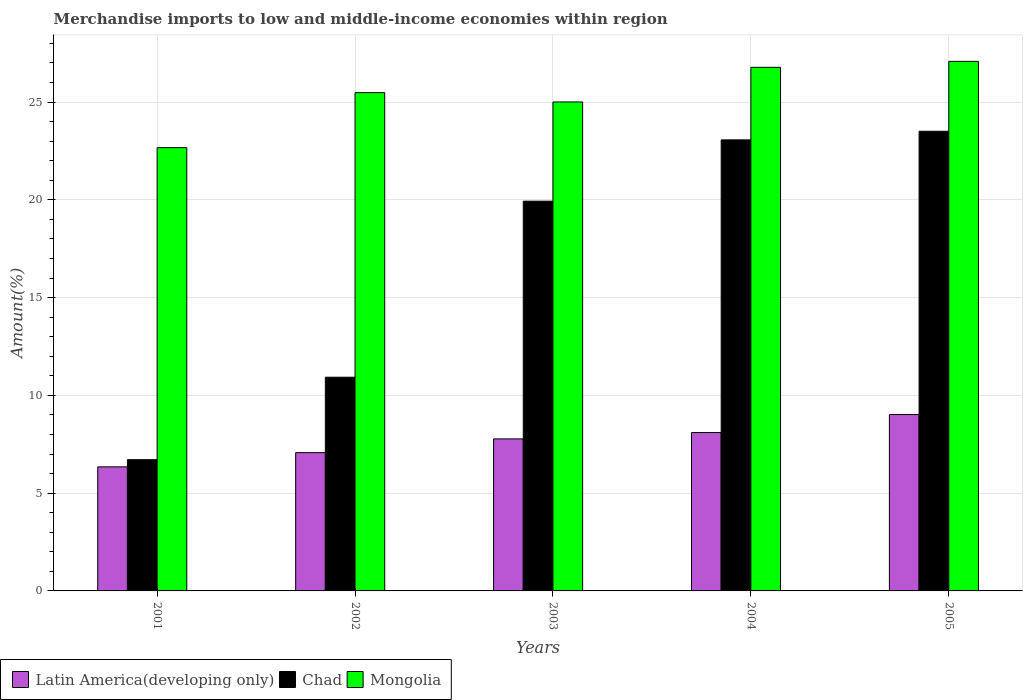Are the number of bars per tick equal to the number of legend labels?
Your response must be concise. Yes. Are the number of bars on each tick of the X-axis equal?
Offer a terse response. Yes. How many bars are there on the 4th tick from the right?
Your answer should be compact. 3. What is the label of the 1st group of bars from the left?
Your answer should be very brief. 2001. What is the percentage of amount earned from merchandise imports in Chad in 2005?
Offer a very short reply. 23.51. Across all years, what is the maximum percentage of amount earned from merchandise imports in Chad?
Offer a terse response. 23.51. Across all years, what is the minimum percentage of amount earned from merchandise imports in Mongolia?
Your answer should be compact. 22.67. In which year was the percentage of amount earned from merchandise imports in Chad maximum?
Your answer should be compact. 2005. What is the total percentage of amount earned from merchandise imports in Mongolia in the graph?
Offer a terse response. 127.01. What is the difference between the percentage of amount earned from merchandise imports in Chad in 2001 and that in 2003?
Provide a succinct answer. -13.22. What is the difference between the percentage of amount earned from merchandise imports in Mongolia in 2005 and the percentage of amount earned from merchandise imports in Latin America(developing only) in 2003?
Make the answer very short. 19.31. What is the average percentage of amount earned from merchandise imports in Chad per year?
Make the answer very short. 16.83. In the year 2003, what is the difference between the percentage of amount earned from merchandise imports in Chad and percentage of amount earned from merchandise imports in Mongolia?
Your response must be concise. -5.07. In how many years, is the percentage of amount earned from merchandise imports in Latin America(developing only) greater than 14 %?
Your answer should be very brief. 0. What is the ratio of the percentage of amount earned from merchandise imports in Latin America(developing only) in 2001 to that in 2004?
Ensure brevity in your answer.  0.78. What is the difference between the highest and the second highest percentage of amount earned from merchandise imports in Mongolia?
Keep it short and to the point. 0.3. What is the difference between the highest and the lowest percentage of amount earned from merchandise imports in Latin America(developing only)?
Keep it short and to the point. 2.68. What does the 3rd bar from the left in 2003 represents?
Provide a short and direct response. Mongolia. What does the 3rd bar from the right in 2002 represents?
Your answer should be very brief. Latin America(developing only). Are all the bars in the graph horizontal?
Offer a very short reply. No. How many years are there in the graph?
Your answer should be compact. 5. Does the graph contain any zero values?
Keep it short and to the point. No. Where does the legend appear in the graph?
Provide a succinct answer. Bottom left. How many legend labels are there?
Offer a terse response. 3. How are the legend labels stacked?
Provide a short and direct response. Horizontal. What is the title of the graph?
Make the answer very short. Merchandise imports to low and middle-income economies within region. Does "Sao Tome and Principe" appear as one of the legend labels in the graph?
Ensure brevity in your answer.  No. What is the label or title of the X-axis?
Provide a succinct answer. Years. What is the label or title of the Y-axis?
Keep it short and to the point. Amount(%). What is the Amount(%) in Latin America(developing only) in 2001?
Provide a short and direct response. 6.34. What is the Amount(%) in Chad in 2001?
Keep it short and to the point. 6.71. What is the Amount(%) in Mongolia in 2001?
Your answer should be compact. 22.67. What is the Amount(%) of Latin America(developing only) in 2002?
Keep it short and to the point. 7.07. What is the Amount(%) in Chad in 2002?
Ensure brevity in your answer.  10.93. What is the Amount(%) in Mongolia in 2002?
Ensure brevity in your answer.  25.48. What is the Amount(%) of Latin America(developing only) in 2003?
Offer a very short reply. 7.77. What is the Amount(%) in Chad in 2003?
Make the answer very short. 19.93. What is the Amount(%) of Mongolia in 2003?
Ensure brevity in your answer.  25. What is the Amount(%) of Latin America(developing only) in 2004?
Offer a terse response. 8.1. What is the Amount(%) of Chad in 2004?
Keep it short and to the point. 23.06. What is the Amount(%) in Mongolia in 2004?
Your response must be concise. 26.78. What is the Amount(%) in Latin America(developing only) in 2005?
Offer a terse response. 9.02. What is the Amount(%) of Chad in 2005?
Your answer should be very brief. 23.51. What is the Amount(%) in Mongolia in 2005?
Offer a terse response. 27.08. Across all years, what is the maximum Amount(%) of Latin America(developing only)?
Your response must be concise. 9.02. Across all years, what is the maximum Amount(%) of Chad?
Provide a succinct answer. 23.51. Across all years, what is the maximum Amount(%) in Mongolia?
Your response must be concise. 27.08. Across all years, what is the minimum Amount(%) in Latin America(developing only)?
Your answer should be very brief. 6.34. Across all years, what is the minimum Amount(%) of Chad?
Your answer should be very brief. 6.71. Across all years, what is the minimum Amount(%) of Mongolia?
Ensure brevity in your answer.  22.67. What is the total Amount(%) of Latin America(developing only) in the graph?
Offer a very short reply. 38.31. What is the total Amount(%) in Chad in the graph?
Give a very brief answer. 84.14. What is the total Amount(%) in Mongolia in the graph?
Keep it short and to the point. 127.01. What is the difference between the Amount(%) of Latin America(developing only) in 2001 and that in 2002?
Your response must be concise. -0.73. What is the difference between the Amount(%) in Chad in 2001 and that in 2002?
Ensure brevity in your answer.  -4.22. What is the difference between the Amount(%) of Mongolia in 2001 and that in 2002?
Keep it short and to the point. -2.81. What is the difference between the Amount(%) of Latin America(developing only) in 2001 and that in 2003?
Give a very brief answer. -1.43. What is the difference between the Amount(%) in Chad in 2001 and that in 2003?
Provide a succinct answer. -13.22. What is the difference between the Amount(%) in Mongolia in 2001 and that in 2003?
Give a very brief answer. -2.34. What is the difference between the Amount(%) in Latin America(developing only) in 2001 and that in 2004?
Ensure brevity in your answer.  -1.75. What is the difference between the Amount(%) of Chad in 2001 and that in 2004?
Make the answer very short. -16.35. What is the difference between the Amount(%) of Mongolia in 2001 and that in 2004?
Offer a very short reply. -4.11. What is the difference between the Amount(%) of Latin America(developing only) in 2001 and that in 2005?
Your answer should be very brief. -2.68. What is the difference between the Amount(%) in Chad in 2001 and that in 2005?
Your answer should be compact. -16.8. What is the difference between the Amount(%) in Mongolia in 2001 and that in 2005?
Ensure brevity in your answer.  -4.41. What is the difference between the Amount(%) in Latin America(developing only) in 2002 and that in 2003?
Provide a short and direct response. -0.7. What is the difference between the Amount(%) in Chad in 2002 and that in 2003?
Provide a succinct answer. -9. What is the difference between the Amount(%) in Mongolia in 2002 and that in 2003?
Offer a terse response. 0.48. What is the difference between the Amount(%) of Latin America(developing only) in 2002 and that in 2004?
Your answer should be very brief. -1.03. What is the difference between the Amount(%) in Chad in 2002 and that in 2004?
Your answer should be compact. -12.14. What is the difference between the Amount(%) in Mongolia in 2002 and that in 2004?
Your answer should be very brief. -1.29. What is the difference between the Amount(%) of Latin America(developing only) in 2002 and that in 2005?
Offer a terse response. -1.95. What is the difference between the Amount(%) of Chad in 2002 and that in 2005?
Ensure brevity in your answer.  -12.58. What is the difference between the Amount(%) in Mongolia in 2002 and that in 2005?
Give a very brief answer. -1.6. What is the difference between the Amount(%) in Latin America(developing only) in 2003 and that in 2004?
Make the answer very short. -0.33. What is the difference between the Amount(%) of Chad in 2003 and that in 2004?
Offer a very short reply. -3.13. What is the difference between the Amount(%) in Mongolia in 2003 and that in 2004?
Your response must be concise. -1.77. What is the difference between the Amount(%) of Latin America(developing only) in 2003 and that in 2005?
Your answer should be compact. -1.25. What is the difference between the Amount(%) in Chad in 2003 and that in 2005?
Your answer should be compact. -3.58. What is the difference between the Amount(%) of Mongolia in 2003 and that in 2005?
Keep it short and to the point. -2.08. What is the difference between the Amount(%) of Latin America(developing only) in 2004 and that in 2005?
Offer a terse response. -0.92. What is the difference between the Amount(%) in Chad in 2004 and that in 2005?
Keep it short and to the point. -0.44. What is the difference between the Amount(%) in Mongolia in 2004 and that in 2005?
Provide a succinct answer. -0.3. What is the difference between the Amount(%) in Latin America(developing only) in 2001 and the Amount(%) in Chad in 2002?
Provide a short and direct response. -4.58. What is the difference between the Amount(%) of Latin America(developing only) in 2001 and the Amount(%) of Mongolia in 2002?
Give a very brief answer. -19.14. What is the difference between the Amount(%) of Chad in 2001 and the Amount(%) of Mongolia in 2002?
Your answer should be very brief. -18.77. What is the difference between the Amount(%) of Latin America(developing only) in 2001 and the Amount(%) of Chad in 2003?
Offer a very short reply. -13.59. What is the difference between the Amount(%) of Latin America(developing only) in 2001 and the Amount(%) of Mongolia in 2003?
Make the answer very short. -18.66. What is the difference between the Amount(%) in Chad in 2001 and the Amount(%) in Mongolia in 2003?
Provide a short and direct response. -18.29. What is the difference between the Amount(%) in Latin America(developing only) in 2001 and the Amount(%) in Chad in 2004?
Your response must be concise. -16.72. What is the difference between the Amount(%) in Latin America(developing only) in 2001 and the Amount(%) in Mongolia in 2004?
Provide a short and direct response. -20.43. What is the difference between the Amount(%) of Chad in 2001 and the Amount(%) of Mongolia in 2004?
Offer a very short reply. -20.07. What is the difference between the Amount(%) in Latin America(developing only) in 2001 and the Amount(%) in Chad in 2005?
Your answer should be very brief. -17.16. What is the difference between the Amount(%) in Latin America(developing only) in 2001 and the Amount(%) in Mongolia in 2005?
Give a very brief answer. -20.74. What is the difference between the Amount(%) in Chad in 2001 and the Amount(%) in Mongolia in 2005?
Ensure brevity in your answer.  -20.37. What is the difference between the Amount(%) of Latin America(developing only) in 2002 and the Amount(%) of Chad in 2003?
Make the answer very short. -12.86. What is the difference between the Amount(%) of Latin America(developing only) in 2002 and the Amount(%) of Mongolia in 2003?
Offer a very short reply. -17.93. What is the difference between the Amount(%) of Chad in 2002 and the Amount(%) of Mongolia in 2003?
Give a very brief answer. -14.08. What is the difference between the Amount(%) in Latin America(developing only) in 2002 and the Amount(%) in Chad in 2004?
Make the answer very short. -15.99. What is the difference between the Amount(%) of Latin America(developing only) in 2002 and the Amount(%) of Mongolia in 2004?
Offer a terse response. -19.7. What is the difference between the Amount(%) of Chad in 2002 and the Amount(%) of Mongolia in 2004?
Make the answer very short. -15.85. What is the difference between the Amount(%) in Latin America(developing only) in 2002 and the Amount(%) in Chad in 2005?
Provide a short and direct response. -16.43. What is the difference between the Amount(%) of Latin America(developing only) in 2002 and the Amount(%) of Mongolia in 2005?
Offer a very short reply. -20.01. What is the difference between the Amount(%) of Chad in 2002 and the Amount(%) of Mongolia in 2005?
Keep it short and to the point. -16.15. What is the difference between the Amount(%) in Latin America(developing only) in 2003 and the Amount(%) in Chad in 2004?
Ensure brevity in your answer.  -15.29. What is the difference between the Amount(%) in Latin America(developing only) in 2003 and the Amount(%) in Mongolia in 2004?
Your answer should be very brief. -19. What is the difference between the Amount(%) of Chad in 2003 and the Amount(%) of Mongolia in 2004?
Your answer should be compact. -6.85. What is the difference between the Amount(%) of Latin America(developing only) in 2003 and the Amount(%) of Chad in 2005?
Give a very brief answer. -15.73. What is the difference between the Amount(%) of Latin America(developing only) in 2003 and the Amount(%) of Mongolia in 2005?
Give a very brief answer. -19.31. What is the difference between the Amount(%) in Chad in 2003 and the Amount(%) in Mongolia in 2005?
Make the answer very short. -7.15. What is the difference between the Amount(%) in Latin America(developing only) in 2004 and the Amount(%) in Chad in 2005?
Offer a very short reply. -15.41. What is the difference between the Amount(%) of Latin America(developing only) in 2004 and the Amount(%) of Mongolia in 2005?
Your answer should be very brief. -18.98. What is the difference between the Amount(%) in Chad in 2004 and the Amount(%) in Mongolia in 2005?
Give a very brief answer. -4.02. What is the average Amount(%) of Latin America(developing only) per year?
Provide a succinct answer. 7.66. What is the average Amount(%) in Chad per year?
Your answer should be compact. 16.83. What is the average Amount(%) in Mongolia per year?
Make the answer very short. 25.4. In the year 2001, what is the difference between the Amount(%) in Latin America(developing only) and Amount(%) in Chad?
Provide a succinct answer. -0.37. In the year 2001, what is the difference between the Amount(%) of Latin America(developing only) and Amount(%) of Mongolia?
Your answer should be compact. -16.32. In the year 2001, what is the difference between the Amount(%) in Chad and Amount(%) in Mongolia?
Offer a very short reply. -15.96. In the year 2002, what is the difference between the Amount(%) in Latin America(developing only) and Amount(%) in Chad?
Provide a short and direct response. -3.86. In the year 2002, what is the difference between the Amount(%) in Latin America(developing only) and Amount(%) in Mongolia?
Your answer should be very brief. -18.41. In the year 2002, what is the difference between the Amount(%) in Chad and Amount(%) in Mongolia?
Provide a short and direct response. -14.55. In the year 2003, what is the difference between the Amount(%) in Latin America(developing only) and Amount(%) in Chad?
Your answer should be very brief. -12.16. In the year 2003, what is the difference between the Amount(%) in Latin America(developing only) and Amount(%) in Mongolia?
Your answer should be compact. -17.23. In the year 2003, what is the difference between the Amount(%) in Chad and Amount(%) in Mongolia?
Provide a short and direct response. -5.07. In the year 2004, what is the difference between the Amount(%) of Latin America(developing only) and Amount(%) of Chad?
Give a very brief answer. -14.97. In the year 2004, what is the difference between the Amount(%) in Latin America(developing only) and Amount(%) in Mongolia?
Provide a short and direct response. -18.68. In the year 2004, what is the difference between the Amount(%) in Chad and Amount(%) in Mongolia?
Keep it short and to the point. -3.71. In the year 2005, what is the difference between the Amount(%) of Latin America(developing only) and Amount(%) of Chad?
Your answer should be compact. -14.49. In the year 2005, what is the difference between the Amount(%) of Latin America(developing only) and Amount(%) of Mongolia?
Provide a succinct answer. -18.06. In the year 2005, what is the difference between the Amount(%) of Chad and Amount(%) of Mongolia?
Offer a very short reply. -3.57. What is the ratio of the Amount(%) of Latin America(developing only) in 2001 to that in 2002?
Offer a terse response. 0.9. What is the ratio of the Amount(%) of Chad in 2001 to that in 2002?
Offer a very short reply. 0.61. What is the ratio of the Amount(%) in Mongolia in 2001 to that in 2002?
Offer a terse response. 0.89. What is the ratio of the Amount(%) of Latin America(developing only) in 2001 to that in 2003?
Provide a short and direct response. 0.82. What is the ratio of the Amount(%) of Chad in 2001 to that in 2003?
Your answer should be very brief. 0.34. What is the ratio of the Amount(%) in Mongolia in 2001 to that in 2003?
Make the answer very short. 0.91. What is the ratio of the Amount(%) of Latin America(developing only) in 2001 to that in 2004?
Offer a very short reply. 0.78. What is the ratio of the Amount(%) in Chad in 2001 to that in 2004?
Offer a very short reply. 0.29. What is the ratio of the Amount(%) of Mongolia in 2001 to that in 2004?
Ensure brevity in your answer.  0.85. What is the ratio of the Amount(%) in Latin America(developing only) in 2001 to that in 2005?
Give a very brief answer. 0.7. What is the ratio of the Amount(%) of Chad in 2001 to that in 2005?
Give a very brief answer. 0.29. What is the ratio of the Amount(%) of Mongolia in 2001 to that in 2005?
Your response must be concise. 0.84. What is the ratio of the Amount(%) of Latin America(developing only) in 2002 to that in 2003?
Make the answer very short. 0.91. What is the ratio of the Amount(%) in Chad in 2002 to that in 2003?
Your response must be concise. 0.55. What is the ratio of the Amount(%) of Mongolia in 2002 to that in 2003?
Make the answer very short. 1.02. What is the ratio of the Amount(%) in Latin America(developing only) in 2002 to that in 2004?
Your answer should be very brief. 0.87. What is the ratio of the Amount(%) of Chad in 2002 to that in 2004?
Your answer should be very brief. 0.47. What is the ratio of the Amount(%) in Mongolia in 2002 to that in 2004?
Your answer should be very brief. 0.95. What is the ratio of the Amount(%) in Latin America(developing only) in 2002 to that in 2005?
Ensure brevity in your answer.  0.78. What is the ratio of the Amount(%) in Chad in 2002 to that in 2005?
Provide a short and direct response. 0.46. What is the ratio of the Amount(%) of Mongolia in 2002 to that in 2005?
Offer a very short reply. 0.94. What is the ratio of the Amount(%) in Latin America(developing only) in 2003 to that in 2004?
Make the answer very short. 0.96. What is the ratio of the Amount(%) in Chad in 2003 to that in 2004?
Provide a succinct answer. 0.86. What is the ratio of the Amount(%) of Mongolia in 2003 to that in 2004?
Ensure brevity in your answer.  0.93. What is the ratio of the Amount(%) in Latin America(developing only) in 2003 to that in 2005?
Keep it short and to the point. 0.86. What is the ratio of the Amount(%) in Chad in 2003 to that in 2005?
Provide a short and direct response. 0.85. What is the ratio of the Amount(%) in Mongolia in 2003 to that in 2005?
Provide a succinct answer. 0.92. What is the ratio of the Amount(%) of Latin America(developing only) in 2004 to that in 2005?
Offer a terse response. 0.9. What is the ratio of the Amount(%) of Chad in 2004 to that in 2005?
Make the answer very short. 0.98. What is the difference between the highest and the second highest Amount(%) in Latin America(developing only)?
Offer a very short reply. 0.92. What is the difference between the highest and the second highest Amount(%) of Chad?
Your answer should be compact. 0.44. What is the difference between the highest and the second highest Amount(%) of Mongolia?
Offer a terse response. 0.3. What is the difference between the highest and the lowest Amount(%) of Latin America(developing only)?
Your answer should be compact. 2.68. What is the difference between the highest and the lowest Amount(%) of Chad?
Give a very brief answer. 16.8. What is the difference between the highest and the lowest Amount(%) of Mongolia?
Give a very brief answer. 4.41. 